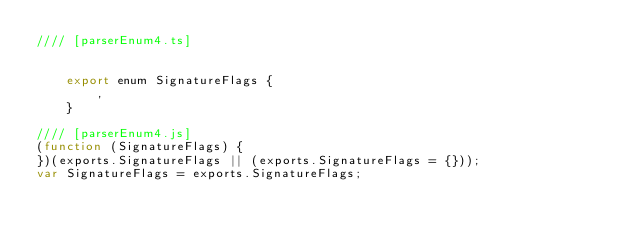<code> <loc_0><loc_0><loc_500><loc_500><_JavaScript_>//// [parserEnum4.ts]


    export enum SignatureFlags {
        ,
    }

//// [parserEnum4.js]
(function (SignatureFlags) {
})(exports.SignatureFlags || (exports.SignatureFlags = {}));
var SignatureFlags = exports.SignatureFlags;
</code> 